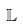<formula> <loc_0><loc_0><loc_500><loc_500>\mathbb { L }</formula> 